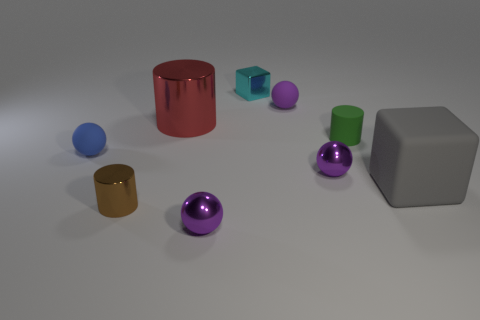How many objects are metal cubes that are right of the big red cylinder or big yellow cubes?
Give a very brief answer. 1. What is the shape of the large gray object that is the same material as the tiny green thing?
Provide a succinct answer. Cube. What shape is the gray matte thing?
Your answer should be compact. Cube. There is a shiny object that is both to the right of the large metallic cylinder and on the left side of the small cyan metal object; what is its color?
Ensure brevity in your answer.  Purple. The green rubber object that is the same size as the brown metallic cylinder is what shape?
Provide a short and direct response. Cylinder. Is there a cyan metal object of the same shape as the blue rubber thing?
Ensure brevity in your answer.  No. Do the cyan cube and the purple thing that is in front of the tiny brown metal thing have the same material?
Offer a terse response. Yes. The small shiny ball to the right of the purple metal object in front of the metal thing on the left side of the red cylinder is what color?
Offer a very short reply. Purple. What material is the cylinder that is the same size as the gray matte block?
Offer a very short reply. Metal. How many small cubes have the same material as the small blue thing?
Provide a short and direct response. 0. 